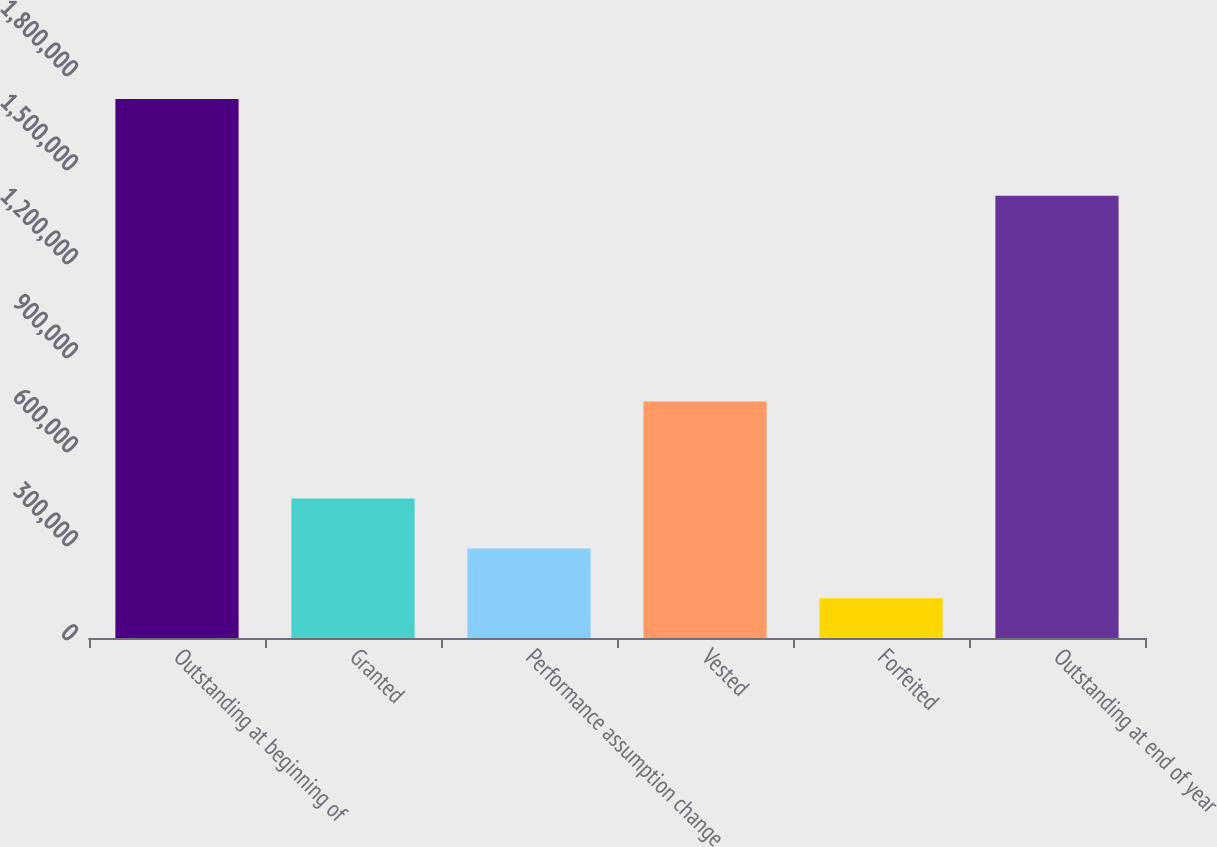Convert chart to OTSL. <chart><loc_0><loc_0><loc_500><loc_500><bar_chart><fcel>Outstanding at beginning of<fcel>Granted<fcel>Performance assumption change<fcel>Vested<fcel>Forfeited<fcel>Outstanding at end of year<nl><fcel>1.72058e+06<fcel>445382<fcel>285982<fcel>754991<fcel>126583<fcel>1.4114e+06<nl></chart> 